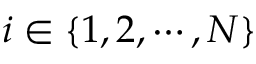Convert formula to latex. <formula><loc_0><loc_0><loc_500><loc_500>i \in \{ 1 , 2 , \cdots , N \}</formula> 